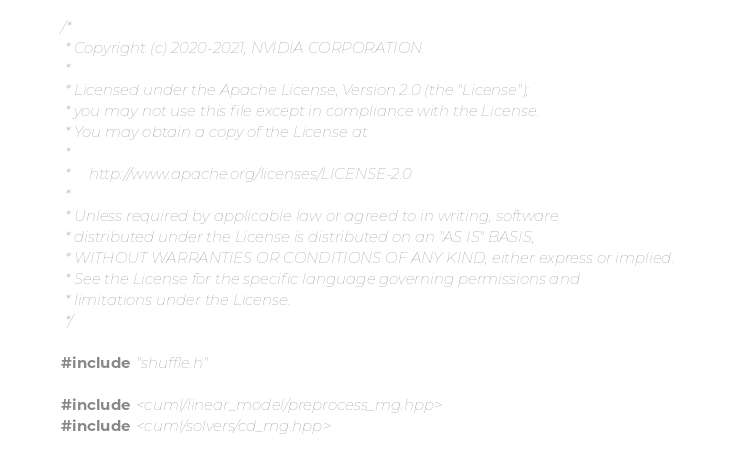Convert code to text. <code><loc_0><loc_0><loc_500><loc_500><_Cuda_>/*
 * Copyright (c) 2020-2021, NVIDIA CORPORATION.
 *
 * Licensed under the Apache License, Version 2.0 (the "License");
 * you may not use this file except in compliance with the License.
 * You may obtain a copy of the License at
 *
 *     http://www.apache.org/licenses/LICENSE-2.0
 *
 * Unless required by applicable law or agreed to in writing, software
 * distributed under the License is distributed on an "AS IS" BASIS,
 * WITHOUT WARRANTIES OR CONDITIONS OF ANY KIND, either express or implied.
 * See the License for the specific language governing permissions and
 * limitations under the License.
 */

#include "shuffle.h"

#include <cuml/linear_model/preprocess_mg.hpp>
#include <cuml/solvers/cd_mg.hpp>
</code> 